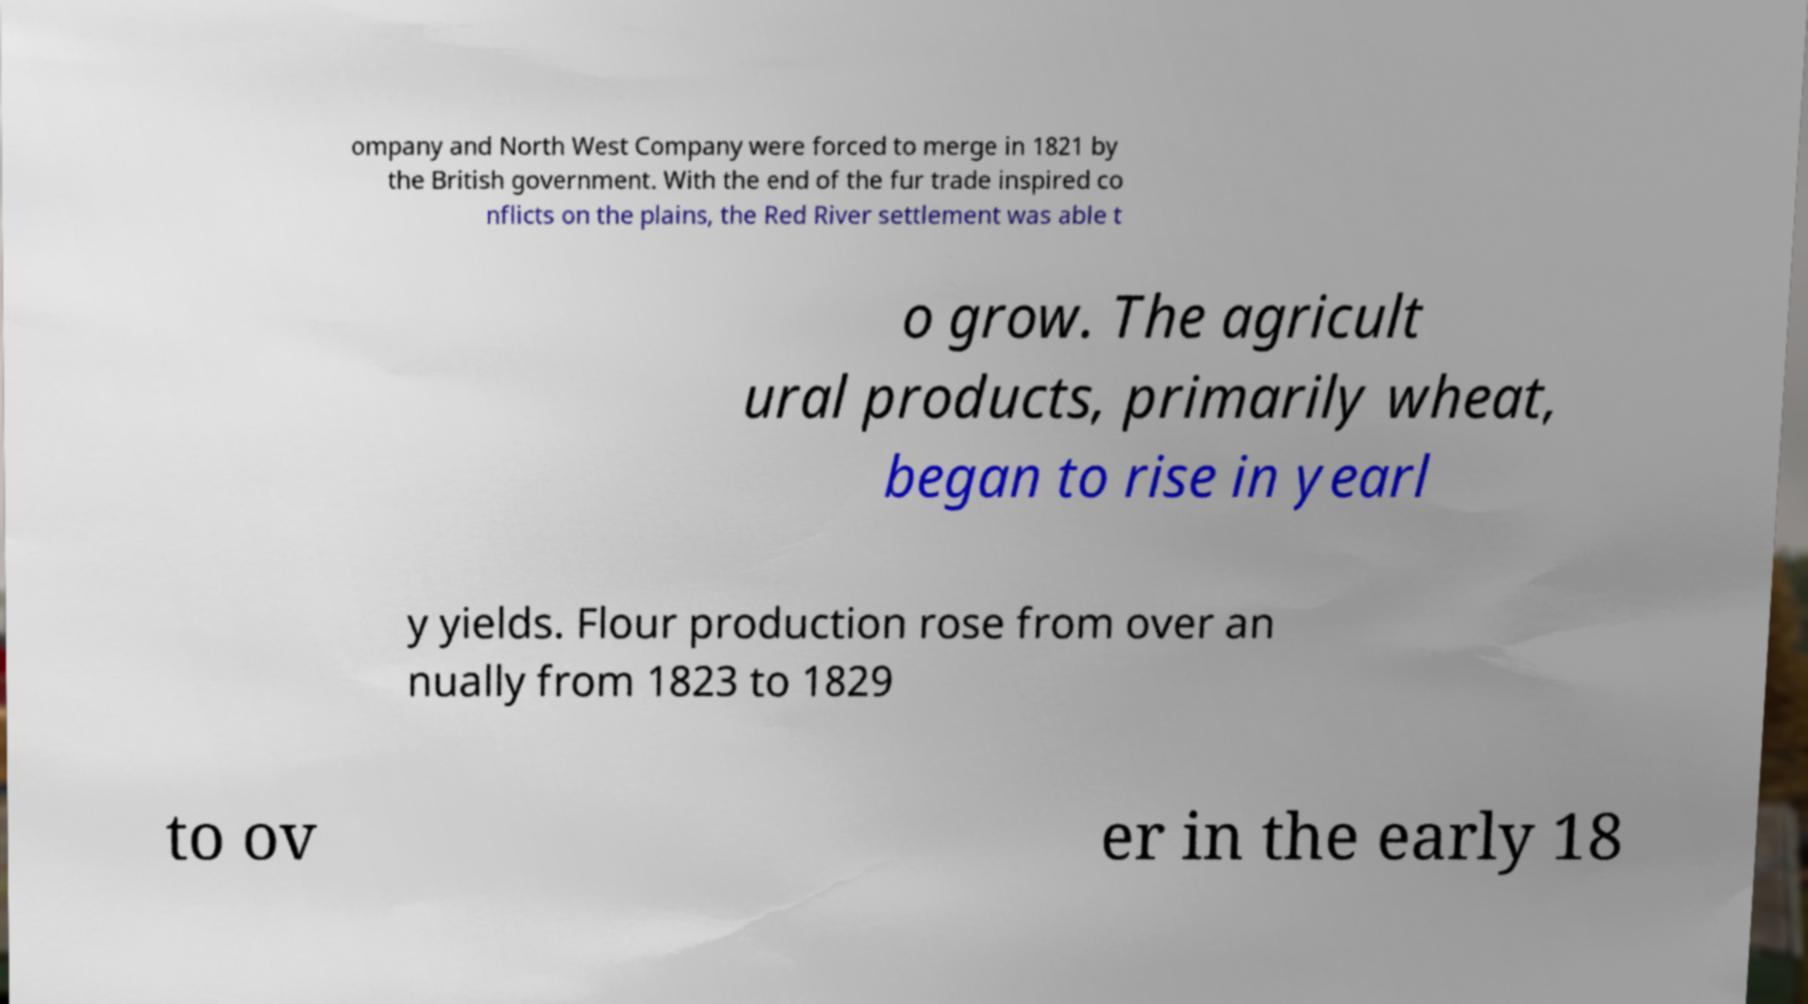I need the written content from this picture converted into text. Can you do that? ompany and North West Company were forced to merge in 1821 by the British government. With the end of the fur trade inspired co nflicts on the plains, the Red River settlement was able t o grow. The agricult ural products, primarily wheat, began to rise in yearl y yields. Flour production rose from over an nually from 1823 to 1829 to ov er in the early 18 